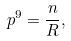<formula> <loc_0><loc_0><loc_500><loc_500>p ^ { 9 } = \frac { n } { R } ,</formula> 